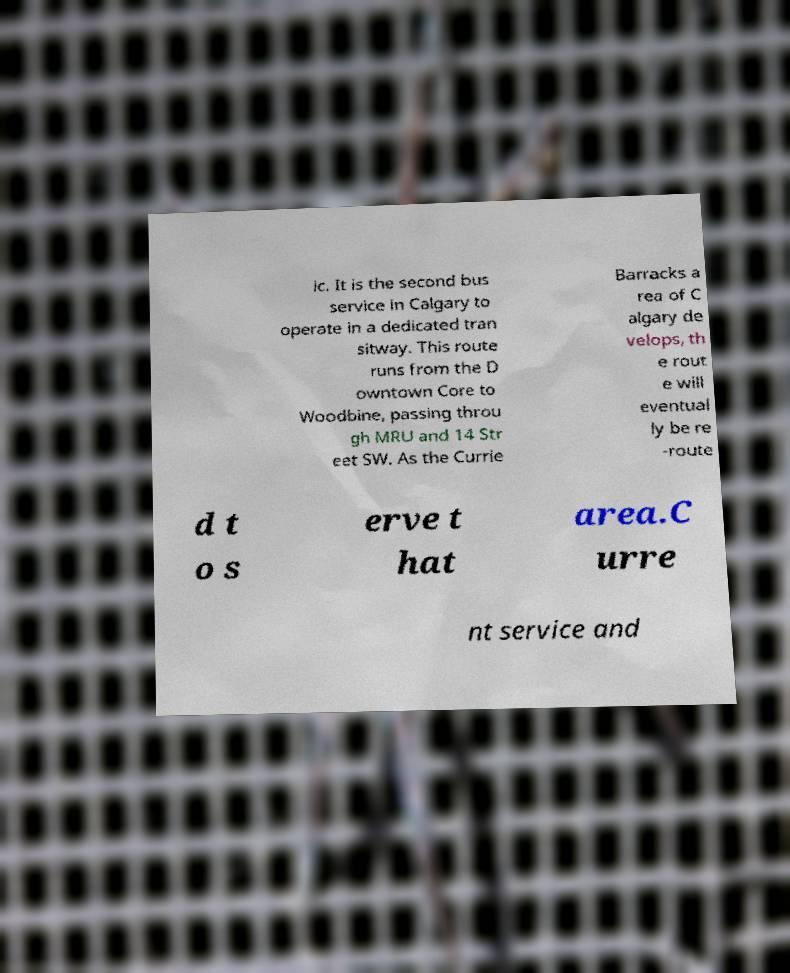Please read and relay the text visible in this image. What does it say? ic. It is the second bus service in Calgary to operate in a dedicated tran sitway. This route runs from the D owntown Core to Woodbine, passing throu gh MRU and 14 Str eet SW. As the Currie Barracks a rea of C algary de velops, th e rout e will eventual ly be re -route d t o s erve t hat area.C urre nt service and 